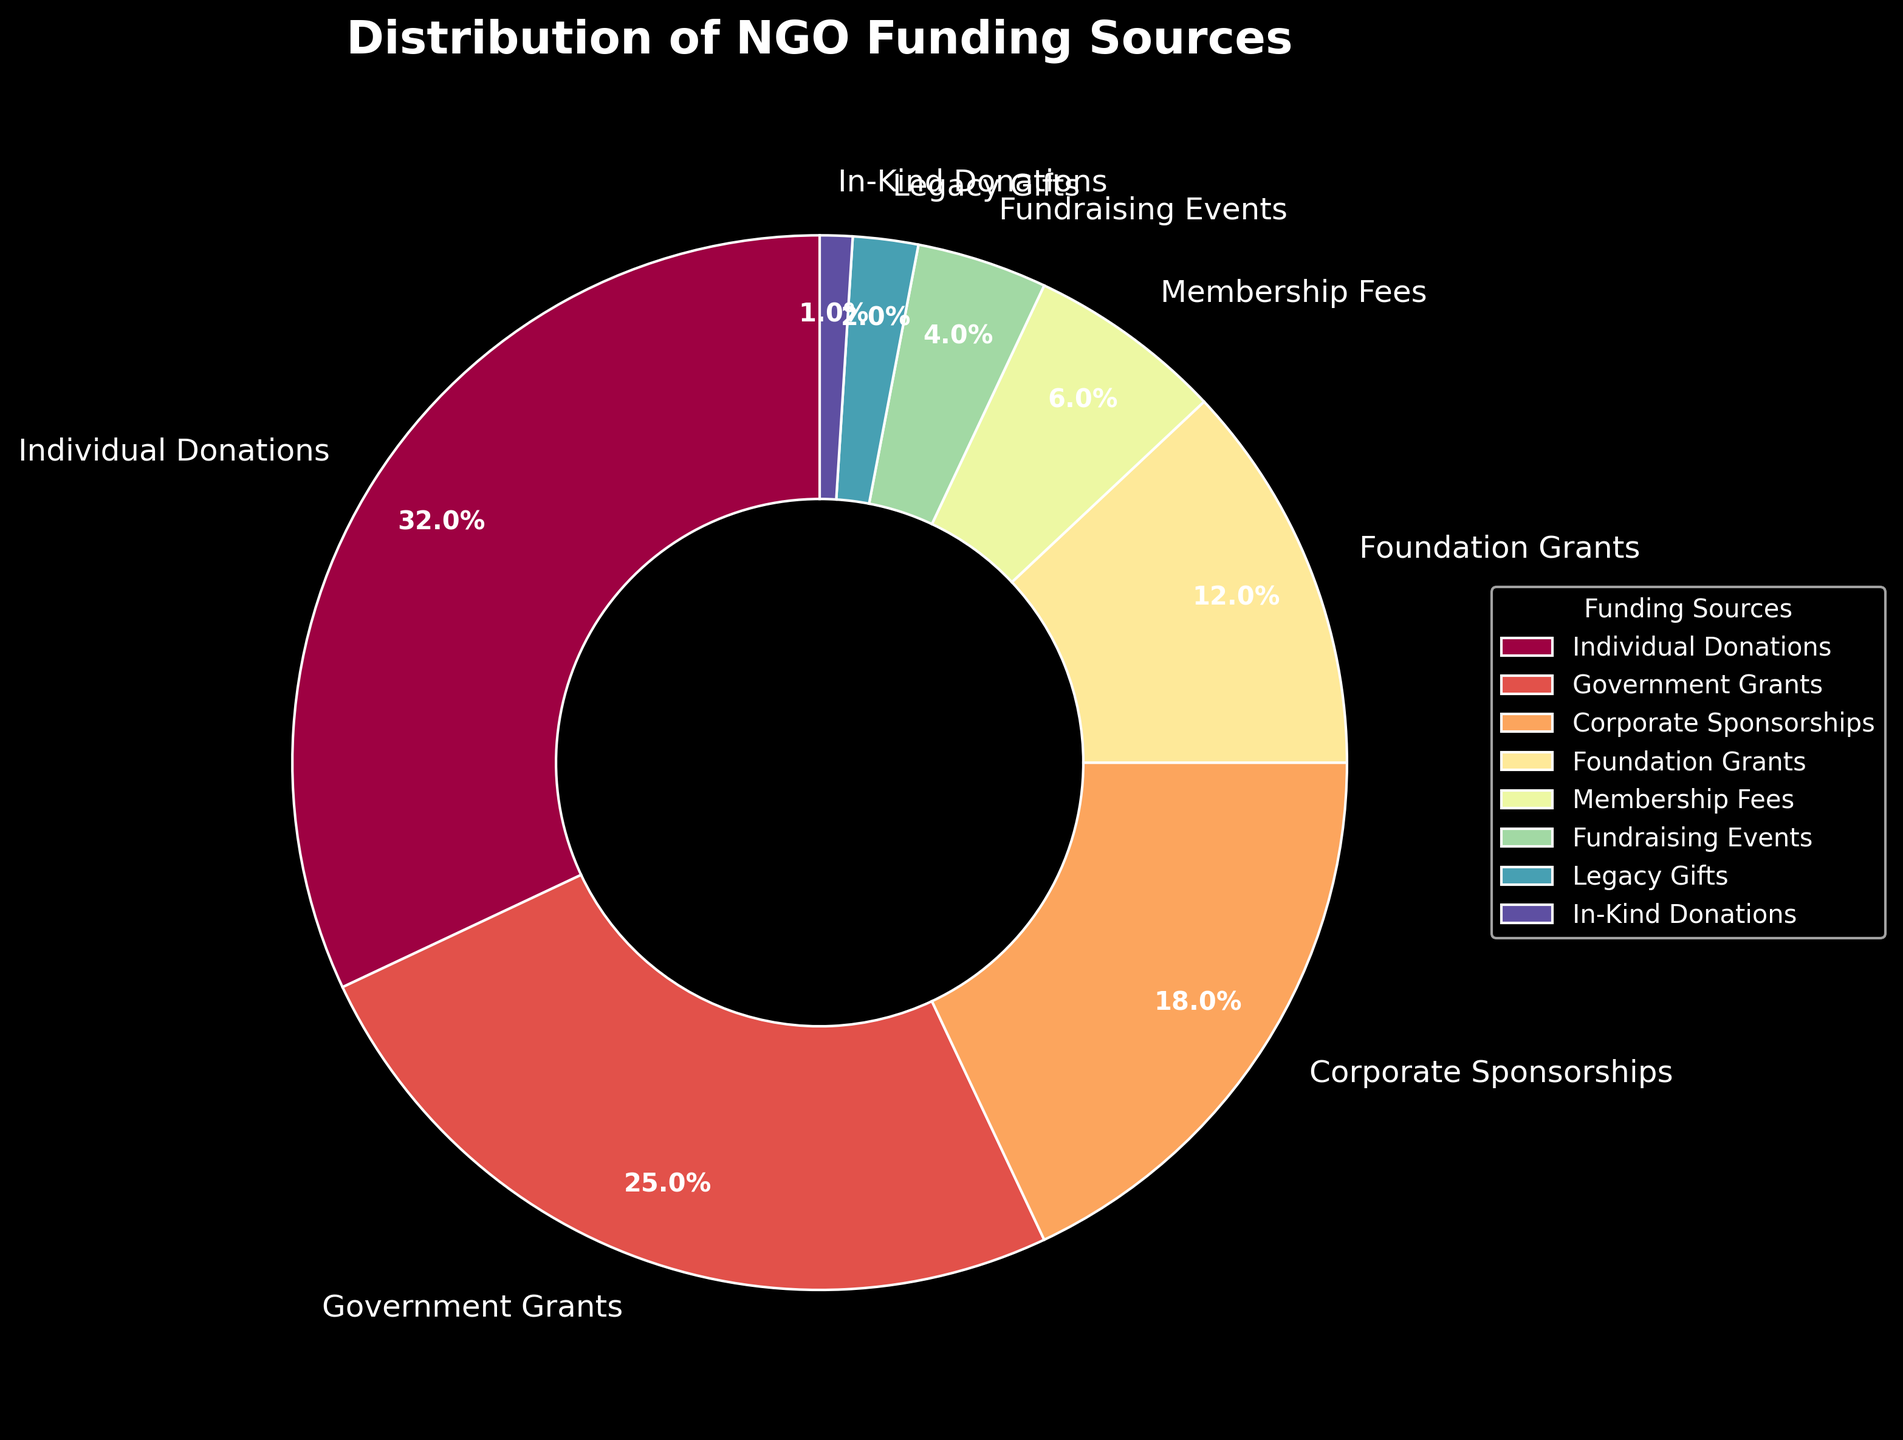What category contributes the highest percentage to the NGO funding sources? The category contributing the highest percentage can be determined by identifying the largest segment of the pie chart. Refer to the label with the largest percentage.
Answer: Individual Donations What is the combined percentage of Government Grants and Foundation Grants? Identify the segments for Government Grants and Foundation Grants on the pie chart and sum their percentages: Government Grants (25%) + Foundation Grants (12%).
Answer: 37% Which category has a larger share, Corporate Sponsorships or Membership Fees? Compare the slices of the pie chart for Corporate Sponsorships and Membership Fees. Corporate Sponsorships is labeled with 18%, while Membership Fees is labeled with 6%.
Answer: Corporate Sponsorships How much more funding do Individual Donations contribute compared to Fundraising Events? Find the percentage for Individual Donations and Fundraising Events, then subtract the latter from the former: Individual Donations (32%) - Fundraising Events (4%).
Answer: 28% Arrange all categories contributing more than 10% of the funding in descending order. Identify all categories exceeding 10% and then order them by their percentage values from highest to lowest: Individual Donations (32%), Government Grants (25%), Corporate Sponsorships (18%), Foundation Grants (12%).
Answer: Individual Donations, Government Grants, Corporate Sponsorships, Foundation Grants What is the smallest funding category and what percentage does it contribute? Look for the smallest segment in the pie chart, which corresponds to In-Kind Donations and note its percentage.
Answer: In-Kind Donations, 1% Which categories together account for at least half of the total funding? Sum the percentages of categories until they meet or exceed 50%. Individual Donations (32%) + Government Grants (25%) = 57%, which is more than half.
Answer: Individual Donations and Government Grants How does the share of Legacy Gifts compare to that of In-Kind Donations? Compare the pie chart segments for Legacy Gifts and In-Kind Donations. Legacy Gifts is labeled with 2%, while In-Kind Donations is labeled with 1%.
Answer: Legacy Gifts has a larger share What is the average percentage of funding contributed by Foundation Grants and Fundraising Events? Calculate the average by summing the percentages of Foundation Grants and Fundraising Events, then dividing by 2: (12% + 4%) / 2.
Answer: 8% What are the three lowest contributing categories and their percentages? Identify the three smallest segments in the pie chart and note their percentages: In-Kind Donations (1%), Legacy Gifts (2%), Fundraising Events (4%).
Answer: In-Kind Donations (1%), Legacy Gifts (2%), Fundraising Events (4%) 